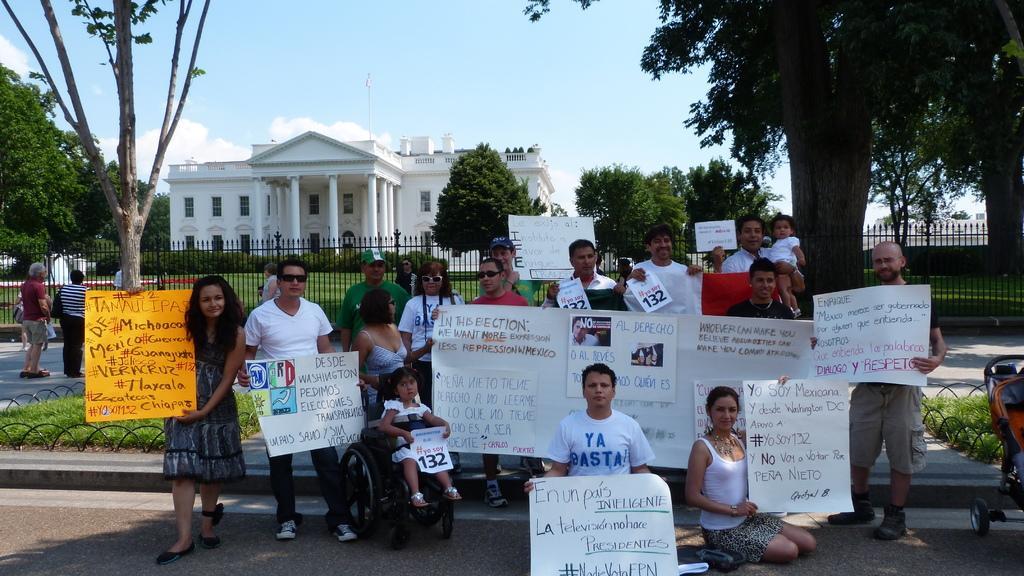Please provide a concise description of this image. In this image there are group of people standing on the floor by holding the charts and posters. Behind them there is a fence. In the background there is a building on which there is a flag. At the top there is the sky. There are trees on either side of the building. In the middle there is a girl sitting in the wheelchair by holding the poster. On the right side there is a cradle on the floor. 